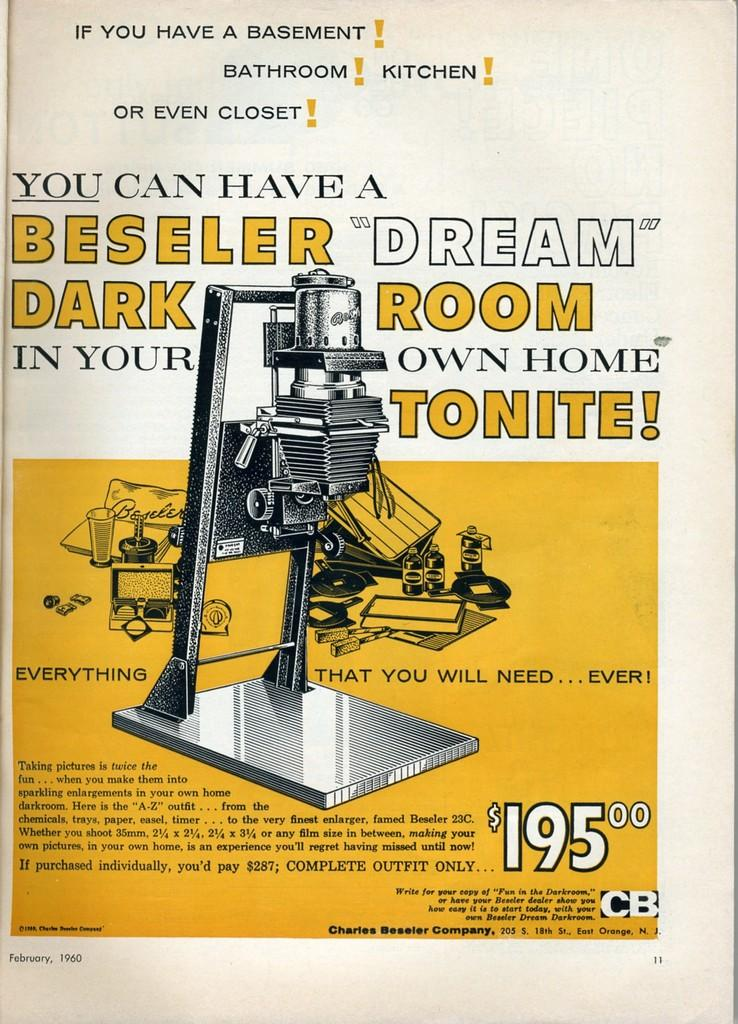Provide a one-sentence caption for the provided image. Ad for a Beseller Dark that is in yellow and white. 